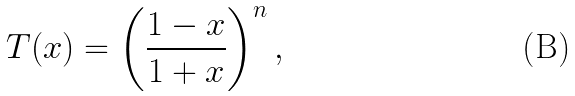<formula> <loc_0><loc_0><loc_500><loc_500>T ( x ) = \left ( \frac { 1 - x } { 1 + x } \right ) ^ { n } ,</formula> 